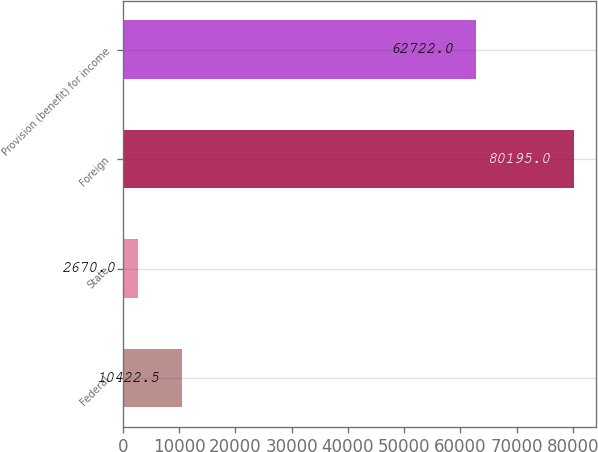Convert chart. <chart><loc_0><loc_0><loc_500><loc_500><bar_chart><fcel>Federal<fcel>State<fcel>Foreign<fcel>Provision (benefit) for income<nl><fcel>10422.5<fcel>2670<fcel>80195<fcel>62722<nl></chart> 